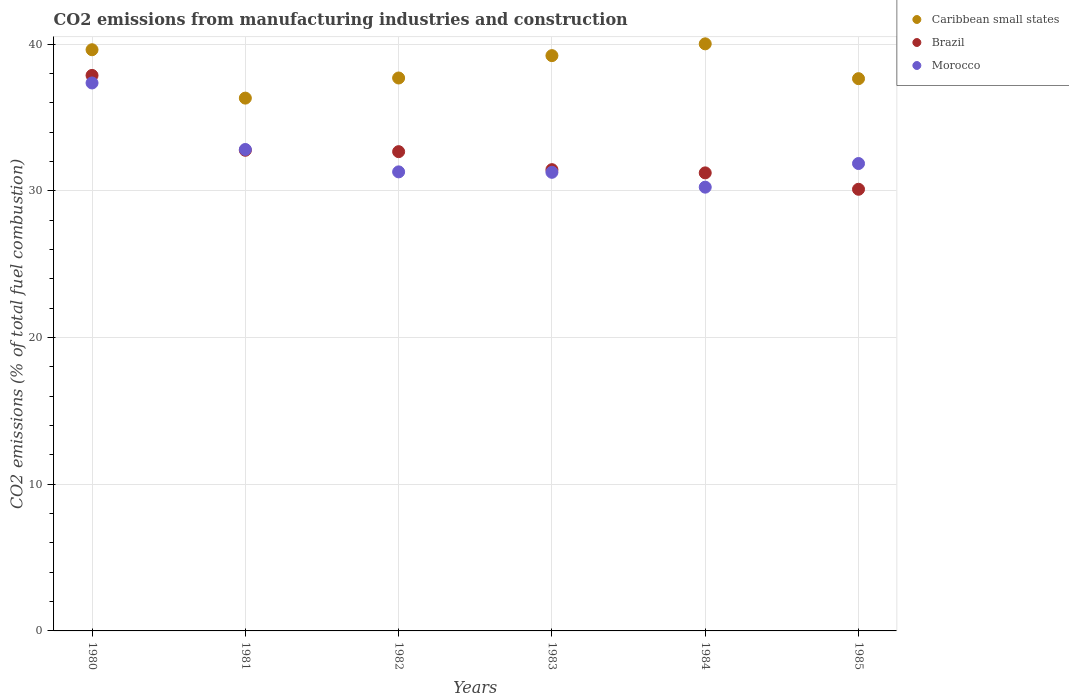Is the number of dotlines equal to the number of legend labels?
Your response must be concise. Yes. What is the amount of CO2 emitted in Morocco in 1981?
Your answer should be compact. 32.81. Across all years, what is the maximum amount of CO2 emitted in Brazil?
Your response must be concise. 37.86. Across all years, what is the minimum amount of CO2 emitted in Morocco?
Keep it short and to the point. 30.25. What is the total amount of CO2 emitted in Caribbean small states in the graph?
Ensure brevity in your answer.  230.48. What is the difference between the amount of CO2 emitted in Morocco in 1982 and that in 1983?
Keep it short and to the point. 0.03. What is the difference between the amount of CO2 emitted in Caribbean small states in 1984 and the amount of CO2 emitted in Brazil in 1981?
Make the answer very short. 7.25. What is the average amount of CO2 emitted in Brazil per year?
Make the answer very short. 32.67. In the year 1984, what is the difference between the amount of CO2 emitted in Morocco and amount of CO2 emitted in Caribbean small states?
Give a very brief answer. -9.77. In how many years, is the amount of CO2 emitted in Brazil greater than 8 %?
Offer a very short reply. 6. What is the ratio of the amount of CO2 emitted in Caribbean small states in 1982 to that in 1983?
Your answer should be very brief. 0.96. Is the amount of CO2 emitted in Brazil in 1981 less than that in 1982?
Provide a succinct answer. No. What is the difference between the highest and the second highest amount of CO2 emitted in Brazil?
Provide a succinct answer. 5.1. What is the difference between the highest and the lowest amount of CO2 emitted in Caribbean small states?
Provide a succinct answer. 3.7. In how many years, is the amount of CO2 emitted in Brazil greater than the average amount of CO2 emitted in Brazil taken over all years?
Provide a short and direct response. 2. Is the amount of CO2 emitted in Brazil strictly less than the amount of CO2 emitted in Caribbean small states over the years?
Give a very brief answer. Yes. How many years are there in the graph?
Offer a very short reply. 6. Are the values on the major ticks of Y-axis written in scientific E-notation?
Offer a very short reply. No. Does the graph contain grids?
Ensure brevity in your answer.  Yes. How many legend labels are there?
Give a very brief answer. 3. What is the title of the graph?
Provide a succinct answer. CO2 emissions from manufacturing industries and construction. Does "Finland" appear as one of the legend labels in the graph?
Your answer should be compact. No. What is the label or title of the Y-axis?
Offer a very short reply. CO2 emissions (% of total fuel combustion). What is the CO2 emissions (% of total fuel combustion) in Caribbean small states in 1980?
Offer a terse response. 39.61. What is the CO2 emissions (% of total fuel combustion) in Brazil in 1980?
Your response must be concise. 37.86. What is the CO2 emissions (% of total fuel combustion) of Morocco in 1980?
Keep it short and to the point. 37.35. What is the CO2 emissions (% of total fuel combustion) in Caribbean small states in 1981?
Make the answer very short. 36.31. What is the CO2 emissions (% of total fuel combustion) of Brazil in 1981?
Give a very brief answer. 32.76. What is the CO2 emissions (% of total fuel combustion) of Morocco in 1981?
Keep it short and to the point. 32.81. What is the CO2 emissions (% of total fuel combustion) of Caribbean small states in 1982?
Your answer should be very brief. 37.69. What is the CO2 emissions (% of total fuel combustion) in Brazil in 1982?
Provide a short and direct response. 32.67. What is the CO2 emissions (% of total fuel combustion) in Morocco in 1982?
Provide a succinct answer. 31.29. What is the CO2 emissions (% of total fuel combustion) of Caribbean small states in 1983?
Your answer should be compact. 39.21. What is the CO2 emissions (% of total fuel combustion) of Brazil in 1983?
Provide a succinct answer. 31.44. What is the CO2 emissions (% of total fuel combustion) of Morocco in 1983?
Provide a short and direct response. 31.26. What is the CO2 emissions (% of total fuel combustion) in Caribbean small states in 1984?
Provide a short and direct response. 40.01. What is the CO2 emissions (% of total fuel combustion) of Brazil in 1984?
Make the answer very short. 31.22. What is the CO2 emissions (% of total fuel combustion) of Morocco in 1984?
Keep it short and to the point. 30.25. What is the CO2 emissions (% of total fuel combustion) in Caribbean small states in 1985?
Your answer should be compact. 37.64. What is the CO2 emissions (% of total fuel combustion) of Brazil in 1985?
Keep it short and to the point. 30.1. What is the CO2 emissions (% of total fuel combustion) in Morocco in 1985?
Offer a terse response. 31.86. Across all years, what is the maximum CO2 emissions (% of total fuel combustion) of Caribbean small states?
Offer a very short reply. 40.01. Across all years, what is the maximum CO2 emissions (% of total fuel combustion) of Brazil?
Give a very brief answer. 37.86. Across all years, what is the maximum CO2 emissions (% of total fuel combustion) of Morocco?
Keep it short and to the point. 37.35. Across all years, what is the minimum CO2 emissions (% of total fuel combustion) of Caribbean small states?
Keep it short and to the point. 36.31. Across all years, what is the minimum CO2 emissions (% of total fuel combustion) of Brazil?
Your response must be concise. 30.1. Across all years, what is the minimum CO2 emissions (% of total fuel combustion) of Morocco?
Your answer should be compact. 30.25. What is the total CO2 emissions (% of total fuel combustion) of Caribbean small states in the graph?
Ensure brevity in your answer.  230.48. What is the total CO2 emissions (% of total fuel combustion) of Brazil in the graph?
Provide a succinct answer. 196.05. What is the total CO2 emissions (% of total fuel combustion) in Morocco in the graph?
Make the answer very short. 194.81. What is the difference between the CO2 emissions (% of total fuel combustion) of Caribbean small states in 1980 and that in 1981?
Keep it short and to the point. 3.3. What is the difference between the CO2 emissions (% of total fuel combustion) in Brazil in 1980 and that in 1981?
Ensure brevity in your answer.  5.1. What is the difference between the CO2 emissions (% of total fuel combustion) of Morocco in 1980 and that in 1981?
Your answer should be compact. 4.53. What is the difference between the CO2 emissions (% of total fuel combustion) of Caribbean small states in 1980 and that in 1982?
Provide a succinct answer. 1.93. What is the difference between the CO2 emissions (% of total fuel combustion) in Brazil in 1980 and that in 1982?
Make the answer very short. 5.2. What is the difference between the CO2 emissions (% of total fuel combustion) in Morocco in 1980 and that in 1982?
Your answer should be very brief. 6.06. What is the difference between the CO2 emissions (% of total fuel combustion) in Caribbean small states in 1980 and that in 1983?
Your answer should be very brief. 0.4. What is the difference between the CO2 emissions (% of total fuel combustion) in Brazil in 1980 and that in 1983?
Provide a short and direct response. 6.42. What is the difference between the CO2 emissions (% of total fuel combustion) in Morocco in 1980 and that in 1983?
Keep it short and to the point. 6.09. What is the difference between the CO2 emissions (% of total fuel combustion) in Caribbean small states in 1980 and that in 1984?
Your answer should be very brief. -0.4. What is the difference between the CO2 emissions (% of total fuel combustion) of Brazil in 1980 and that in 1984?
Give a very brief answer. 6.64. What is the difference between the CO2 emissions (% of total fuel combustion) of Morocco in 1980 and that in 1984?
Your answer should be compact. 7.1. What is the difference between the CO2 emissions (% of total fuel combustion) in Caribbean small states in 1980 and that in 1985?
Ensure brevity in your answer.  1.97. What is the difference between the CO2 emissions (% of total fuel combustion) of Brazil in 1980 and that in 1985?
Make the answer very short. 7.76. What is the difference between the CO2 emissions (% of total fuel combustion) in Morocco in 1980 and that in 1985?
Offer a very short reply. 5.49. What is the difference between the CO2 emissions (% of total fuel combustion) in Caribbean small states in 1981 and that in 1982?
Keep it short and to the point. -1.37. What is the difference between the CO2 emissions (% of total fuel combustion) of Brazil in 1981 and that in 1982?
Offer a very short reply. 0.1. What is the difference between the CO2 emissions (% of total fuel combustion) of Morocco in 1981 and that in 1982?
Your answer should be very brief. 1.53. What is the difference between the CO2 emissions (% of total fuel combustion) in Caribbean small states in 1981 and that in 1983?
Make the answer very short. -2.9. What is the difference between the CO2 emissions (% of total fuel combustion) of Brazil in 1981 and that in 1983?
Provide a short and direct response. 1.32. What is the difference between the CO2 emissions (% of total fuel combustion) of Morocco in 1981 and that in 1983?
Your answer should be compact. 1.56. What is the difference between the CO2 emissions (% of total fuel combustion) of Caribbean small states in 1981 and that in 1984?
Provide a short and direct response. -3.7. What is the difference between the CO2 emissions (% of total fuel combustion) of Brazil in 1981 and that in 1984?
Provide a short and direct response. 1.54. What is the difference between the CO2 emissions (% of total fuel combustion) in Morocco in 1981 and that in 1984?
Ensure brevity in your answer.  2.57. What is the difference between the CO2 emissions (% of total fuel combustion) of Caribbean small states in 1981 and that in 1985?
Provide a succinct answer. -1.33. What is the difference between the CO2 emissions (% of total fuel combustion) of Brazil in 1981 and that in 1985?
Provide a short and direct response. 2.66. What is the difference between the CO2 emissions (% of total fuel combustion) of Morocco in 1981 and that in 1985?
Keep it short and to the point. 0.96. What is the difference between the CO2 emissions (% of total fuel combustion) in Caribbean small states in 1982 and that in 1983?
Your answer should be very brief. -1.52. What is the difference between the CO2 emissions (% of total fuel combustion) in Brazil in 1982 and that in 1983?
Offer a terse response. 1.23. What is the difference between the CO2 emissions (% of total fuel combustion) in Morocco in 1982 and that in 1983?
Your answer should be very brief. 0.03. What is the difference between the CO2 emissions (% of total fuel combustion) of Caribbean small states in 1982 and that in 1984?
Ensure brevity in your answer.  -2.33. What is the difference between the CO2 emissions (% of total fuel combustion) in Brazil in 1982 and that in 1984?
Give a very brief answer. 1.45. What is the difference between the CO2 emissions (% of total fuel combustion) in Morocco in 1982 and that in 1984?
Your response must be concise. 1.04. What is the difference between the CO2 emissions (% of total fuel combustion) of Caribbean small states in 1982 and that in 1985?
Make the answer very short. 0.05. What is the difference between the CO2 emissions (% of total fuel combustion) in Brazil in 1982 and that in 1985?
Provide a short and direct response. 2.56. What is the difference between the CO2 emissions (% of total fuel combustion) of Morocco in 1982 and that in 1985?
Your answer should be very brief. -0.57. What is the difference between the CO2 emissions (% of total fuel combustion) of Caribbean small states in 1983 and that in 1984?
Keep it short and to the point. -0.8. What is the difference between the CO2 emissions (% of total fuel combustion) of Brazil in 1983 and that in 1984?
Ensure brevity in your answer.  0.22. What is the difference between the CO2 emissions (% of total fuel combustion) in Morocco in 1983 and that in 1984?
Your response must be concise. 1.01. What is the difference between the CO2 emissions (% of total fuel combustion) in Caribbean small states in 1983 and that in 1985?
Your answer should be very brief. 1.57. What is the difference between the CO2 emissions (% of total fuel combustion) in Brazil in 1983 and that in 1985?
Provide a short and direct response. 1.34. What is the difference between the CO2 emissions (% of total fuel combustion) of Morocco in 1983 and that in 1985?
Offer a very short reply. -0.6. What is the difference between the CO2 emissions (% of total fuel combustion) of Caribbean small states in 1984 and that in 1985?
Provide a succinct answer. 2.37. What is the difference between the CO2 emissions (% of total fuel combustion) of Brazil in 1984 and that in 1985?
Provide a short and direct response. 1.12. What is the difference between the CO2 emissions (% of total fuel combustion) in Morocco in 1984 and that in 1985?
Offer a very short reply. -1.61. What is the difference between the CO2 emissions (% of total fuel combustion) in Caribbean small states in 1980 and the CO2 emissions (% of total fuel combustion) in Brazil in 1981?
Make the answer very short. 6.85. What is the difference between the CO2 emissions (% of total fuel combustion) in Caribbean small states in 1980 and the CO2 emissions (% of total fuel combustion) in Morocco in 1981?
Give a very brief answer. 6.8. What is the difference between the CO2 emissions (% of total fuel combustion) in Brazil in 1980 and the CO2 emissions (% of total fuel combustion) in Morocco in 1981?
Offer a very short reply. 5.05. What is the difference between the CO2 emissions (% of total fuel combustion) of Caribbean small states in 1980 and the CO2 emissions (% of total fuel combustion) of Brazil in 1982?
Provide a succinct answer. 6.95. What is the difference between the CO2 emissions (% of total fuel combustion) of Caribbean small states in 1980 and the CO2 emissions (% of total fuel combustion) of Morocco in 1982?
Ensure brevity in your answer.  8.32. What is the difference between the CO2 emissions (% of total fuel combustion) in Brazil in 1980 and the CO2 emissions (% of total fuel combustion) in Morocco in 1982?
Give a very brief answer. 6.57. What is the difference between the CO2 emissions (% of total fuel combustion) of Caribbean small states in 1980 and the CO2 emissions (% of total fuel combustion) of Brazil in 1983?
Ensure brevity in your answer.  8.17. What is the difference between the CO2 emissions (% of total fuel combustion) in Caribbean small states in 1980 and the CO2 emissions (% of total fuel combustion) in Morocco in 1983?
Offer a terse response. 8.35. What is the difference between the CO2 emissions (% of total fuel combustion) of Brazil in 1980 and the CO2 emissions (% of total fuel combustion) of Morocco in 1983?
Ensure brevity in your answer.  6.6. What is the difference between the CO2 emissions (% of total fuel combustion) of Caribbean small states in 1980 and the CO2 emissions (% of total fuel combustion) of Brazil in 1984?
Keep it short and to the point. 8.39. What is the difference between the CO2 emissions (% of total fuel combustion) in Caribbean small states in 1980 and the CO2 emissions (% of total fuel combustion) in Morocco in 1984?
Offer a very short reply. 9.37. What is the difference between the CO2 emissions (% of total fuel combustion) in Brazil in 1980 and the CO2 emissions (% of total fuel combustion) in Morocco in 1984?
Make the answer very short. 7.62. What is the difference between the CO2 emissions (% of total fuel combustion) of Caribbean small states in 1980 and the CO2 emissions (% of total fuel combustion) of Brazil in 1985?
Your response must be concise. 9.51. What is the difference between the CO2 emissions (% of total fuel combustion) of Caribbean small states in 1980 and the CO2 emissions (% of total fuel combustion) of Morocco in 1985?
Offer a terse response. 7.76. What is the difference between the CO2 emissions (% of total fuel combustion) of Brazil in 1980 and the CO2 emissions (% of total fuel combustion) of Morocco in 1985?
Make the answer very short. 6.01. What is the difference between the CO2 emissions (% of total fuel combustion) of Caribbean small states in 1981 and the CO2 emissions (% of total fuel combustion) of Brazil in 1982?
Keep it short and to the point. 3.65. What is the difference between the CO2 emissions (% of total fuel combustion) in Caribbean small states in 1981 and the CO2 emissions (% of total fuel combustion) in Morocco in 1982?
Ensure brevity in your answer.  5.03. What is the difference between the CO2 emissions (% of total fuel combustion) of Brazil in 1981 and the CO2 emissions (% of total fuel combustion) of Morocco in 1982?
Provide a short and direct response. 1.47. What is the difference between the CO2 emissions (% of total fuel combustion) of Caribbean small states in 1981 and the CO2 emissions (% of total fuel combustion) of Brazil in 1983?
Offer a terse response. 4.88. What is the difference between the CO2 emissions (% of total fuel combustion) in Caribbean small states in 1981 and the CO2 emissions (% of total fuel combustion) in Morocco in 1983?
Ensure brevity in your answer.  5.06. What is the difference between the CO2 emissions (% of total fuel combustion) in Brazil in 1981 and the CO2 emissions (% of total fuel combustion) in Morocco in 1983?
Your answer should be very brief. 1.5. What is the difference between the CO2 emissions (% of total fuel combustion) of Caribbean small states in 1981 and the CO2 emissions (% of total fuel combustion) of Brazil in 1984?
Your response must be concise. 5.1. What is the difference between the CO2 emissions (% of total fuel combustion) of Caribbean small states in 1981 and the CO2 emissions (% of total fuel combustion) of Morocco in 1984?
Offer a terse response. 6.07. What is the difference between the CO2 emissions (% of total fuel combustion) of Brazil in 1981 and the CO2 emissions (% of total fuel combustion) of Morocco in 1984?
Offer a very short reply. 2.52. What is the difference between the CO2 emissions (% of total fuel combustion) of Caribbean small states in 1981 and the CO2 emissions (% of total fuel combustion) of Brazil in 1985?
Your answer should be compact. 6.21. What is the difference between the CO2 emissions (% of total fuel combustion) of Caribbean small states in 1981 and the CO2 emissions (% of total fuel combustion) of Morocco in 1985?
Offer a terse response. 4.46. What is the difference between the CO2 emissions (% of total fuel combustion) in Brazil in 1981 and the CO2 emissions (% of total fuel combustion) in Morocco in 1985?
Ensure brevity in your answer.  0.9. What is the difference between the CO2 emissions (% of total fuel combustion) of Caribbean small states in 1982 and the CO2 emissions (% of total fuel combustion) of Brazil in 1983?
Keep it short and to the point. 6.25. What is the difference between the CO2 emissions (% of total fuel combustion) in Caribbean small states in 1982 and the CO2 emissions (% of total fuel combustion) in Morocco in 1983?
Give a very brief answer. 6.43. What is the difference between the CO2 emissions (% of total fuel combustion) in Brazil in 1982 and the CO2 emissions (% of total fuel combustion) in Morocco in 1983?
Your answer should be very brief. 1.41. What is the difference between the CO2 emissions (% of total fuel combustion) of Caribbean small states in 1982 and the CO2 emissions (% of total fuel combustion) of Brazil in 1984?
Give a very brief answer. 6.47. What is the difference between the CO2 emissions (% of total fuel combustion) of Caribbean small states in 1982 and the CO2 emissions (% of total fuel combustion) of Morocco in 1984?
Ensure brevity in your answer.  7.44. What is the difference between the CO2 emissions (% of total fuel combustion) of Brazil in 1982 and the CO2 emissions (% of total fuel combustion) of Morocco in 1984?
Your answer should be compact. 2.42. What is the difference between the CO2 emissions (% of total fuel combustion) of Caribbean small states in 1982 and the CO2 emissions (% of total fuel combustion) of Brazil in 1985?
Offer a terse response. 7.58. What is the difference between the CO2 emissions (% of total fuel combustion) in Caribbean small states in 1982 and the CO2 emissions (% of total fuel combustion) in Morocco in 1985?
Your answer should be compact. 5.83. What is the difference between the CO2 emissions (% of total fuel combustion) in Brazil in 1982 and the CO2 emissions (% of total fuel combustion) in Morocco in 1985?
Your answer should be compact. 0.81. What is the difference between the CO2 emissions (% of total fuel combustion) of Caribbean small states in 1983 and the CO2 emissions (% of total fuel combustion) of Brazil in 1984?
Provide a short and direct response. 7.99. What is the difference between the CO2 emissions (% of total fuel combustion) of Caribbean small states in 1983 and the CO2 emissions (% of total fuel combustion) of Morocco in 1984?
Your response must be concise. 8.96. What is the difference between the CO2 emissions (% of total fuel combustion) in Brazil in 1983 and the CO2 emissions (% of total fuel combustion) in Morocco in 1984?
Your answer should be compact. 1.19. What is the difference between the CO2 emissions (% of total fuel combustion) of Caribbean small states in 1983 and the CO2 emissions (% of total fuel combustion) of Brazil in 1985?
Provide a succinct answer. 9.11. What is the difference between the CO2 emissions (% of total fuel combustion) of Caribbean small states in 1983 and the CO2 emissions (% of total fuel combustion) of Morocco in 1985?
Offer a terse response. 7.35. What is the difference between the CO2 emissions (% of total fuel combustion) in Brazil in 1983 and the CO2 emissions (% of total fuel combustion) in Morocco in 1985?
Keep it short and to the point. -0.42. What is the difference between the CO2 emissions (% of total fuel combustion) in Caribbean small states in 1984 and the CO2 emissions (% of total fuel combustion) in Brazil in 1985?
Ensure brevity in your answer.  9.91. What is the difference between the CO2 emissions (% of total fuel combustion) in Caribbean small states in 1984 and the CO2 emissions (% of total fuel combustion) in Morocco in 1985?
Provide a short and direct response. 8.16. What is the difference between the CO2 emissions (% of total fuel combustion) in Brazil in 1984 and the CO2 emissions (% of total fuel combustion) in Morocco in 1985?
Give a very brief answer. -0.64. What is the average CO2 emissions (% of total fuel combustion) of Caribbean small states per year?
Your answer should be compact. 38.41. What is the average CO2 emissions (% of total fuel combustion) in Brazil per year?
Give a very brief answer. 32.67. What is the average CO2 emissions (% of total fuel combustion) of Morocco per year?
Provide a short and direct response. 32.47. In the year 1980, what is the difference between the CO2 emissions (% of total fuel combustion) in Caribbean small states and CO2 emissions (% of total fuel combustion) in Brazil?
Make the answer very short. 1.75. In the year 1980, what is the difference between the CO2 emissions (% of total fuel combustion) in Caribbean small states and CO2 emissions (% of total fuel combustion) in Morocco?
Ensure brevity in your answer.  2.26. In the year 1980, what is the difference between the CO2 emissions (% of total fuel combustion) in Brazil and CO2 emissions (% of total fuel combustion) in Morocco?
Give a very brief answer. 0.51. In the year 1981, what is the difference between the CO2 emissions (% of total fuel combustion) of Caribbean small states and CO2 emissions (% of total fuel combustion) of Brazil?
Make the answer very short. 3.55. In the year 1981, what is the difference between the CO2 emissions (% of total fuel combustion) of Caribbean small states and CO2 emissions (% of total fuel combustion) of Morocco?
Give a very brief answer. 3.5. In the year 1981, what is the difference between the CO2 emissions (% of total fuel combustion) of Brazil and CO2 emissions (% of total fuel combustion) of Morocco?
Ensure brevity in your answer.  -0.05. In the year 1982, what is the difference between the CO2 emissions (% of total fuel combustion) in Caribbean small states and CO2 emissions (% of total fuel combustion) in Brazil?
Keep it short and to the point. 5.02. In the year 1982, what is the difference between the CO2 emissions (% of total fuel combustion) of Caribbean small states and CO2 emissions (% of total fuel combustion) of Morocco?
Keep it short and to the point. 6.4. In the year 1982, what is the difference between the CO2 emissions (% of total fuel combustion) of Brazil and CO2 emissions (% of total fuel combustion) of Morocco?
Offer a terse response. 1.38. In the year 1983, what is the difference between the CO2 emissions (% of total fuel combustion) of Caribbean small states and CO2 emissions (% of total fuel combustion) of Brazil?
Provide a succinct answer. 7.77. In the year 1983, what is the difference between the CO2 emissions (% of total fuel combustion) of Caribbean small states and CO2 emissions (% of total fuel combustion) of Morocco?
Your answer should be compact. 7.95. In the year 1983, what is the difference between the CO2 emissions (% of total fuel combustion) in Brazil and CO2 emissions (% of total fuel combustion) in Morocco?
Provide a short and direct response. 0.18. In the year 1984, what is the difference between the CO2 emissions (% of total fuel combustion) of Caribbean small states and CO2 emissions (% of total fuel combustion) of Brazil?
Your response must be concise. 8.79. In the year 1984, what is the difference between the CO2 emissions (% of total fuel combustion) in Caribbean small states and CO2 emissions (% of total fuel combustion) in Morocco?
Provide a succinct answer. 9.77. In the year 1984, what is the difference between the CO2 emissions (% of total fuel combustion) in Brazil and CO2 emissions (% of total fuel combustion) in Morocco?
Make the answer very short. 0.97. In the year 1985, what is the difference between the CO2 emissions (% of total fuel combustion) of Caribbean small states and CO2 emissions (% of total fuel combustion) of Brazil?
Your answer should be very brief. 7.54. In the year 1985, what is the difference between the CO2 emissions (% of total fuel combustion) in Caribbean small states and CO2 emissions (% of total fuel combustion) in Morocco?
Keep it short and to the point. 5.78. In the year 1985, what is the difference between the CO2 emissions (% of total fuel combustion) of Brazil and CO2 emissions (% of total fuel combustion) of Morocco?
Provide a succinct answer. -1.76. What is the ratio of the CO2 emissions (% of total fuel combustion) of Caribbean small states in 1980 to that in 1981?
Offer a terse response. 1.09. What is the ratio of the CO2 emissions (% of total fuel combustion) in Brazil in 1980 to that in 1981?
Your response must be concise. 1.16. What is the ratio of the CO2 emissions (% of total fuel combustion) in Morocco in 1980 to that in 1981?
Offer a terse response. 1.14. What is the ratio of the CO2 emissions (% of total fuel combustion) in Caribbean small states in 1980 to that in 1982?
Provide a short and direct response. 1.05. What is the ratio of the CO2 emissions (% of total fuel combustion) in Brazil in 1980 to that in 1982?
Give a very brief answer. 1.16. What is the ratio of the CO2 emissions (% of total fuel combustion) in Morocco in 1980 to that in 1982?
Keep it short and to the point. 1.19. What is the ratio of the CO2 emissions (% of total fuel combustion) in Caribbean small states in 1980 to that in 1983?
Offer a terse response. 1.01. What is the ratio of the CO2 emissions (% of total fuel combustion) of Brazil in 1980 to that in 1983?
Your answer should be very brief. 1.2. What is the ratio of the CO2 emissions (% of total fuel combustion) of Morocco in 1980 to that in 1983?
Make the answer very short. 1.19. What is the ratio of the CO2 emissions (% of total fuel combustion) in Caribbean small states in 1980 to that in 1984?
Ensure brevity in your answer.  0.99. What is the ratio of the CO2 emissions (% of total fuel combustion) of Brazil in 1980 to that in 1984?
Your answer should be very brief. 1.21. What is the ratio of the CO2 emissions (% of total fuel combustion) in Morocco in 1980 to that in 1984?
Provide a short and direct response. 1.23. What is the ratio of the CO2 emissions (% of total fuel combustion) in Caribbean small states in 1980 to that in 1985?
Make the answer very short. 1.05. What is the ratio of the CO2 emissions (% of total fuel combustion) in Brazil in 1980 to that in 1985?
Provide a short and direct response. 1.26. What is the ratio of the CO2 emissions (% of total fuel combustion) of Morocco in 1980 to that in 1985?
Provide a succinct answer. 1.17. What is the ratio of the CO2 emissions (% of total fuel combustion) in Caribbean small states in 1981 to that in 1982?
Provide a succinct answer. 0.96. What is the ratio of the CO2 emissions (% of total fuel combustion) of Brazil in 1981 to that in 1982?
Make the answer very short. 1. What is the ratio of the CO2 emissions (% of total fuel combustion) of Morocco in 1981 to that in 1982?
Keep it short and to the point. 1.05. What is the ratio of the CO2 emissions (% of total fuel combustion) of Caribbean small states in 1981 to that in 1983?
Offer a very short reply. 0.93. What is the ratio of the CO2 emissions (% of total fuel combustion) in Brazil in 1981 to that in 1983?
Make the answer very short. 1.04. What is the ratio of the CO2 emissions (% of total fuel combustion) in Morocco in 1981 to that in 1983?
Your answer should be compact. 1.05. What is the ratio of the CO2 emissions (% of total fuel combustion) in Caribbean small states in 1981 to that in 1984?
Give a very brief answer. 0.91. What is the ratio of the CO2 emissions (% of total fuel combustion) in Brazil in 1981 to that in 1984?
Offer a terse response. 1.05. What is the ratio of the CO2 emissions (% of total fuel combustion) of Morocco in 1981 to that in 1984?
Your answer should be compact. 1.08. What is the ratio of the CO2 emissions (% of total fuel combustion) in Caribbean small states in 1981 to that in 1985?
Offer a terse response. 0.96. What is the ratio of the CO2 emissions (% of total fuel combustion) of Brazil in 1981 to that in 1985?
Ensure brevity in your answer.  1.09. What is the ratio of the CO2 emissions (% of total fuel combustion) in Morocco in 1981 to that in 1985?
Keep it short and to the point. 1.03. What is the ratio of the CO2 emissions (% of total fuel combustion) of Caribbean small states in 1982 to that in 1983?
Keep it short and to the point. 0.96. What is the ratio of the CO2 emissions (% of total fuel combustion) of Brazil in 1982 to that in 1983?
Give a very brief answer. 1.04. What is the ratio of the CO2 emissions (% of total fuel combustion) of Caribbean small states in 1982 to that in 1984?
Offer a very short reply. 0.94. What is the ratio of the CO2 emissions (% of total fuel combustion) in Brazil in 1982 to that in 1984?
Your answer should be very brief. 1.05. What is the ratio of the CO2 emissions (% of total fuel combustion) of Morocco in 1982 to that in 1984?
Your response must be concise. 1.03. What is the ratio of the CO2 emissions (% of total fuel combustion) in Brazil in 1982 to that in 1985?
Keep it short and to the point. 1.09. What is the ratio of the CO2 emissions (% of total fuel combustion) in Morocco in 1982 to that in 1985?
Offer a very short reply. 0.98. What is the ratio of the CO2 emissions (% of total fuel combustion) of Caribbean small states in 1983 to that in 1984?
Ensure brevity in your answer.  0.98. What is the ratio of the CO2 emissions (% of total fuel combustion) in Morocco in 1983 to that in 1984?
Give a very brief answer. 1.03. What is the ratio of the CO2 emissions (% of total fuel combustion) in Caribbean small states in 1983 to that in 1985?
Offer a terse response. 1.04. What is the ratio of the CO2 emissions (% of total fuel combustion) in Brazil in 1983 to that in 1985?
Provide a succinct answer. 1.04. What is the ratio of the CO2 emissions (% of total fuel combustion) of Morocco in 1983 to that in 1985?
Keep it short and to the point. 0.98. What is the ratio of the CO2 emissions (% of total fuel combustion) in Caribbean small states in 1984 to that in 1985?
Offer a very short reply. 1.06. What is the ratio of the CO2 emissions (% of total fuel combustion) of Brazil in 1984 to that in 1985?
Provide a succinct answer. 1.04. What is the ratio of the CO2 emissions (% of total fuel combustion) of Morocco in 1984 to that in 1985?
Your response must be concise. 0.95. What is the difference between the highest and the second highest CO2 emissions (% of total fuel combustion) of Caribbean small states?
Make the answer very short. 0.4. What is the difference between the highest and the second highest CO2 emissions (% of total fuel combustion) of Brazil?
Offer a terse response. 5.1. What is the difference between the highest and the second highest CO2 emissions (% of total fuel combustion) in Morocco?
Ensure brevity in your answer.  4.53. What is the difference between the highest and the lowest CO2 emissions (% of total fuel combustion) in Caribbean small states?
Keep it short and to the point. 3.7. What is the difference between the highest and the lowest CO2 emissions (% of total fuel combustion) of Brazil?
Make the answer very short. 7.76. What is the difference between the highest and the lowest CO2 emissions (% of total fuel combustion) of Morocco?
Your answer should be very brief. 7.1. 